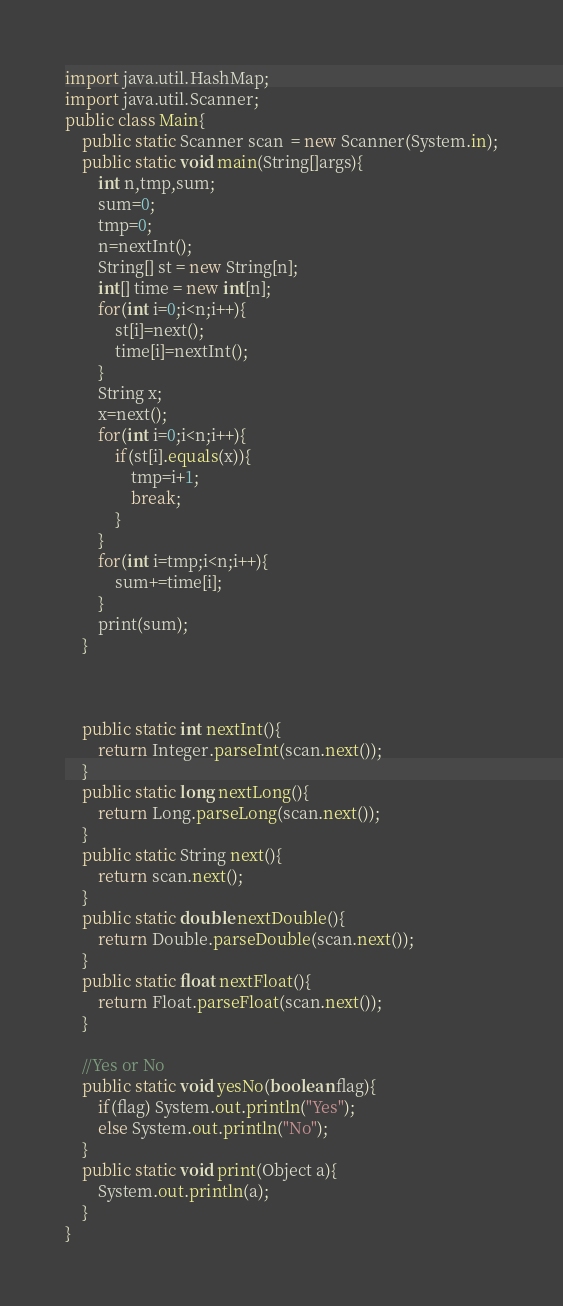<code> <loc_0><loc_0><loc_500><loc_500><_Java_>import java.util.HashMap;
import java.util.Scanner;
public class Main{
    public static Scanner scan  = new Scanner(System.in);
    public static void main(String[]args){
        int n,tmp,sum;
        sum=0;
        tmp=0;
        n=nextInt();
        String[] st = new String[n];
        int[] time = new int[n];
        for(int i=0;i<n;i++){
            st[i]=next();
            time[i]=nextInt();
        }
        String x;
        x=next();
        for(int i=0;i<n;i++){
            if(st[i].equals(x)){
                tmp=i+1;
                break;
            }
        }
        for(int i=tmp;i<n;i++){
            sum+=time[i];
        }
        print(sum);
    }



    public static int nextInt(){
        return Integer.parseInt(scan.next());
    }
    public static long nextLong(){
        return Long.parseLong(scan.next());
    }
    public static String next(){
        return scan.next();
    }
    public static double nextDouble(){
        return Double.parseDouble(scan.next());
    }
    public static float nextFloat(){
        return Float.parseFloat(scan.next());
    }

    //Yes or No
    public static void yesNo(boolean flag){
        if(flag) System.out.println("Yes");
        else System.out.println("No");
    }
    public static void print(Object a){
        System.out.println(a);
    }
}
</code> 